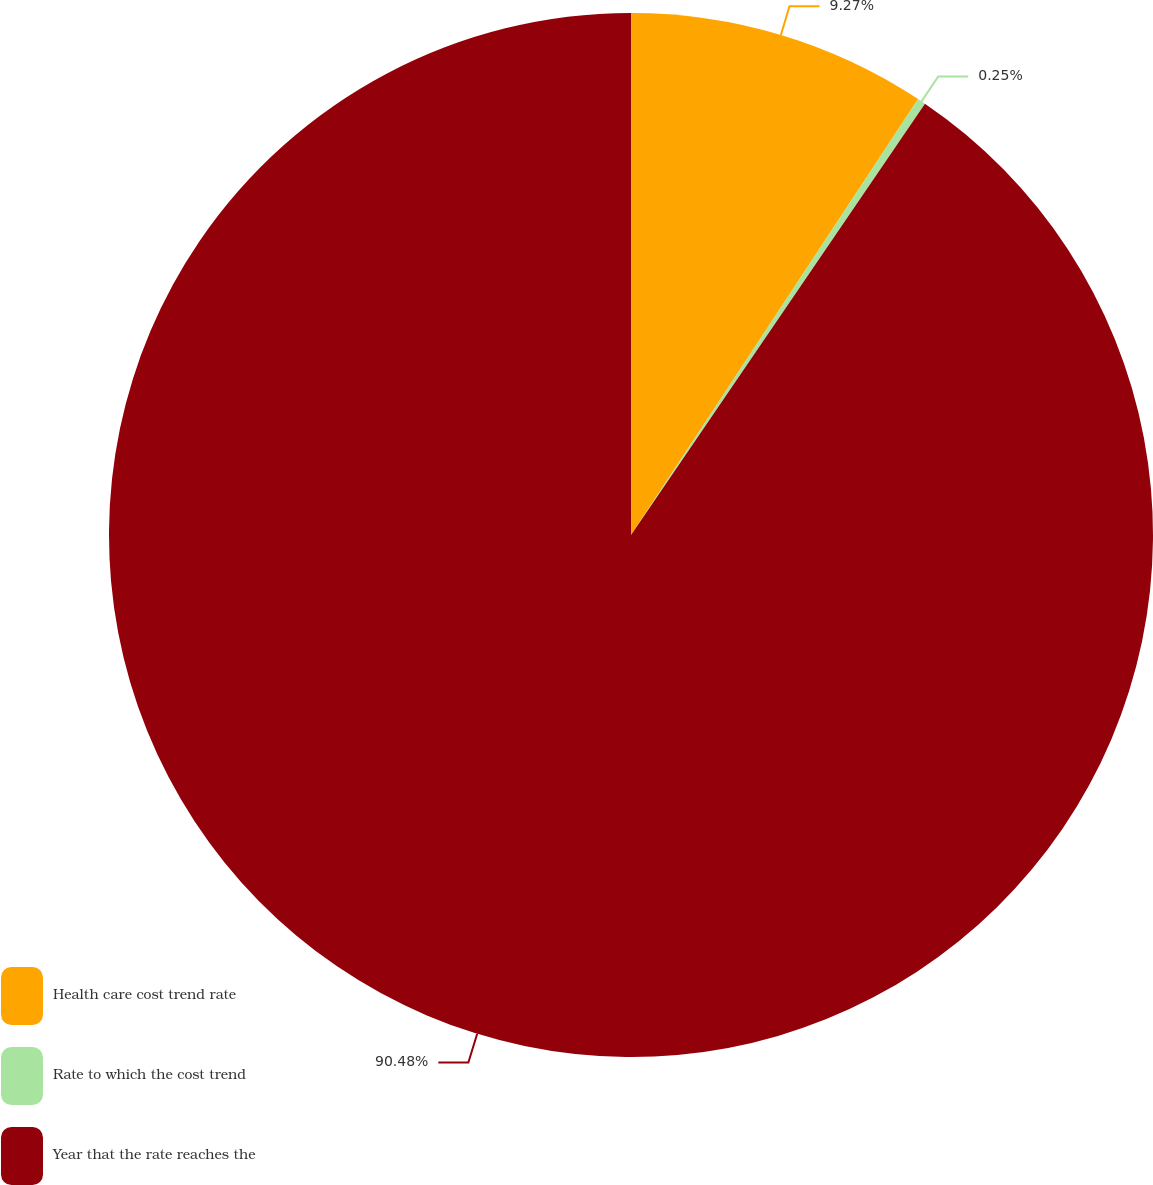<chart> <loc_0><loc_0><loc_500><loc_500><pie_chart><fcel>Health care cost trend rate<fcel>Rate to which the cost trend<fcel>Year that the rate reaches the<nl><fcel>9.27%<fcel>0.25%<fcel>90.48%<nl></chart> 